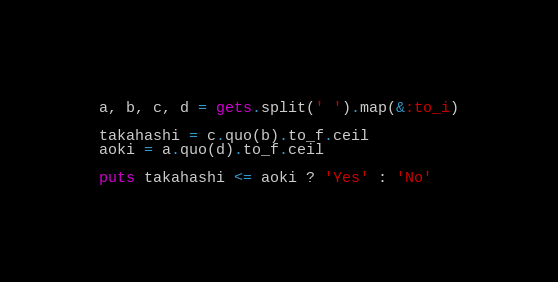<code> <loc_0><loc_0><loc_500><loc_500><_Ruby_>a, b, c, d = gets.split(' ').map(&:to_i)
 
takahashi = c.quo(b).to_f.ceil
aoki = a.quo(d).to_f.ceil
 
puts takahashi <= aoki ? 'Yes' : 'No'</code> 